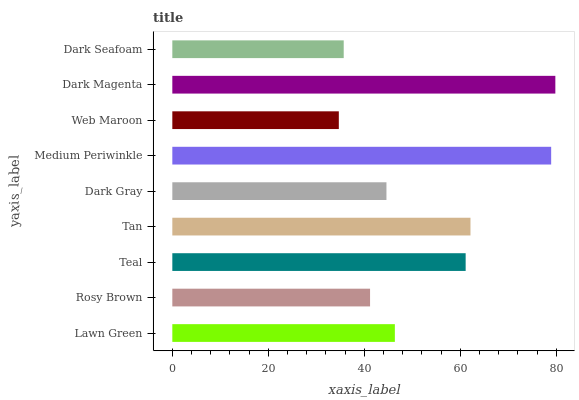Is Web Maroon the minimum?
Answer yes or no. Yes. Is Dark Magenta the maximum?
Answer yes or no. Yes. Is Rosy Brown the minimum?
Answer yes or no. No. Is Rosy Brown the maximum?
Answer yes or no. No. Is Lawn Green greater than Rosy Brown?
Answer yes or no. Yes. Is Rosy Brown less than Lawn Green?
Answer yes or no. Yes. Is Rosy Brown greater than Lawn Green?
Answer yes or no. No. Is Lawn Green less than Rosy Brown?
Answer yes or no. No. Is Lawn Green the high median?
Answer yes or no. Yes. Is Lawn Green the low median?
Answer yes or no. Yes. Is Web Maroon the high median?
Answer yes or no. No. Is Web Maroon the low median?
Answer yes or no. No. 